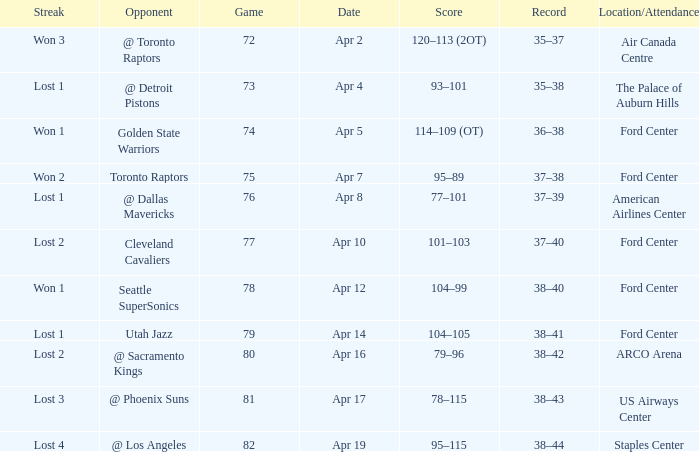Who was the opponent for game 75? Toronto Raptors. 